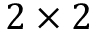<formula> <loc_0><loc_0><loc_500><loc_500>2 \times 2</formula> 